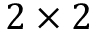<formula> <loc_0><loc_0><loc_500><loc_500>2 \times 2</formula> 